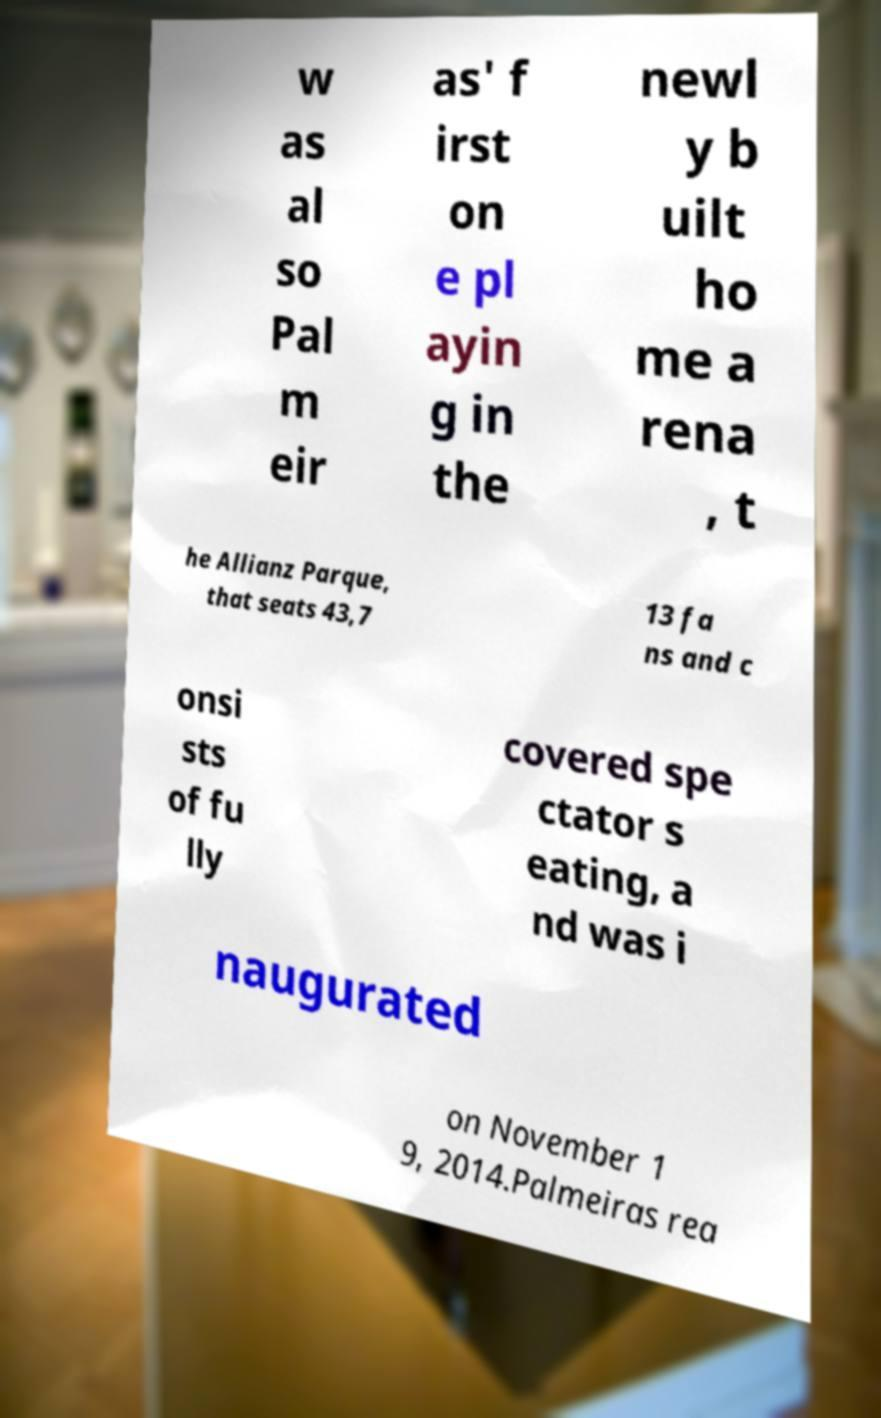What messages or text are displayed in this image? I need them in a readable, typed format. w as al so Pal m eir as' f irst on e pl ayin g in the newl y b uilt ho me a rena , t he Allianz Parque, that seats 43,7 13 fa ns and c onsi sts of fu lly covered spe ctator s eating, a nd was i naugurated on November 1 9, 2014.Palmeiras rea 